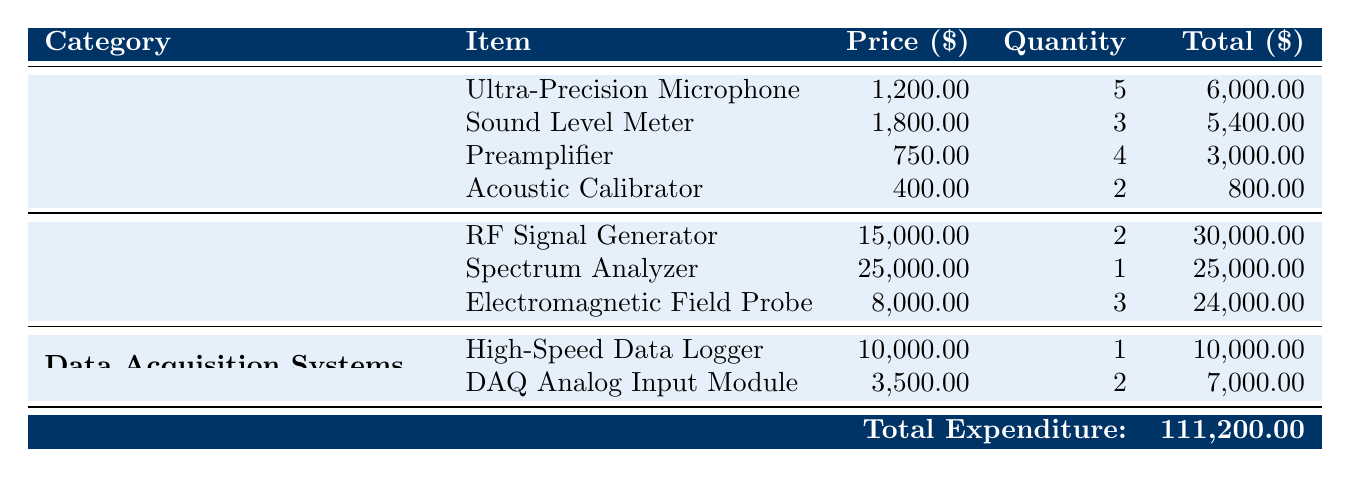What is the total expenditure on Acoustic Equipment? The table lists expenditures for four items under Acoustic Equipment: Ultra-Precision Microphone (6000.00), Sound Level Meter (5400.00), Preamplifier (3000.00), and Acoustic Calibrator (800.00). Adding these amounts together: 6000 + 5400 + 3000 + 800 = 15000.00.
Answer: 15000.00 Which item has the highest price among the expenditures? Among all the items listed, the Spectrum Analyzer has the highest price at 25000.00. This can be identified by comparing the prices of all items in the table.
Answer: 25000.00 How many total pieces of electromagnetic equipment were purchased? There are three items listed under Electromagnetic Equipment: RF Signal Generator (quantity 2), Spectrum Analyzer (quantity 1), and Electromagnetic Field Probe (quantity 3). Adding these quantities gives: 2 + 1 + 3 = 6.
Answer: 6 Is the total expenditure on Data Acquisition Systems less than the total expenditure on Acoustic Equipment? The total for Data Acquisition Systems is 10000.00 + 7000.00 = 17000.00. Since Acoustic Equipment totals 15000.00, 17000.00 is greater than 15000.00, so the answer is no.
Answer: No What is the average expenditure per item in the entire table? Total Expenditure = 111200.00. There are 10 items in total (4 Acoustic, 3 Electromagnetic, 2 Data Acquisition). To find the average, divide total expenditure by the number of items: 111200.00 / 10 = 11120.00.
Answer: 11120.00 What is the combined total for items under the Acoustic Equipment category? To find the total for Acoustic Equipment, we calculate: 6000 + 5400 + 3000 + 800 = 15000.00.
Answer: 15000.00 Is it true that more than one unit of the Electromagnetic Field Probe was purchased? The table indicates that 3 units of the Electromagnetic Field Probe were purchased, which is more than one. Thus, the statement is true.
Answer: Yes Which brand offers the most expensive item in the table? The most expensive item is the Spectrum Analyzer, which is from Keysight Technologies. Since it has the highest price (25000.00), the brand associated with the most expensive item is determined to be Keysight Technologies.
Answer: Keysight Technologies 